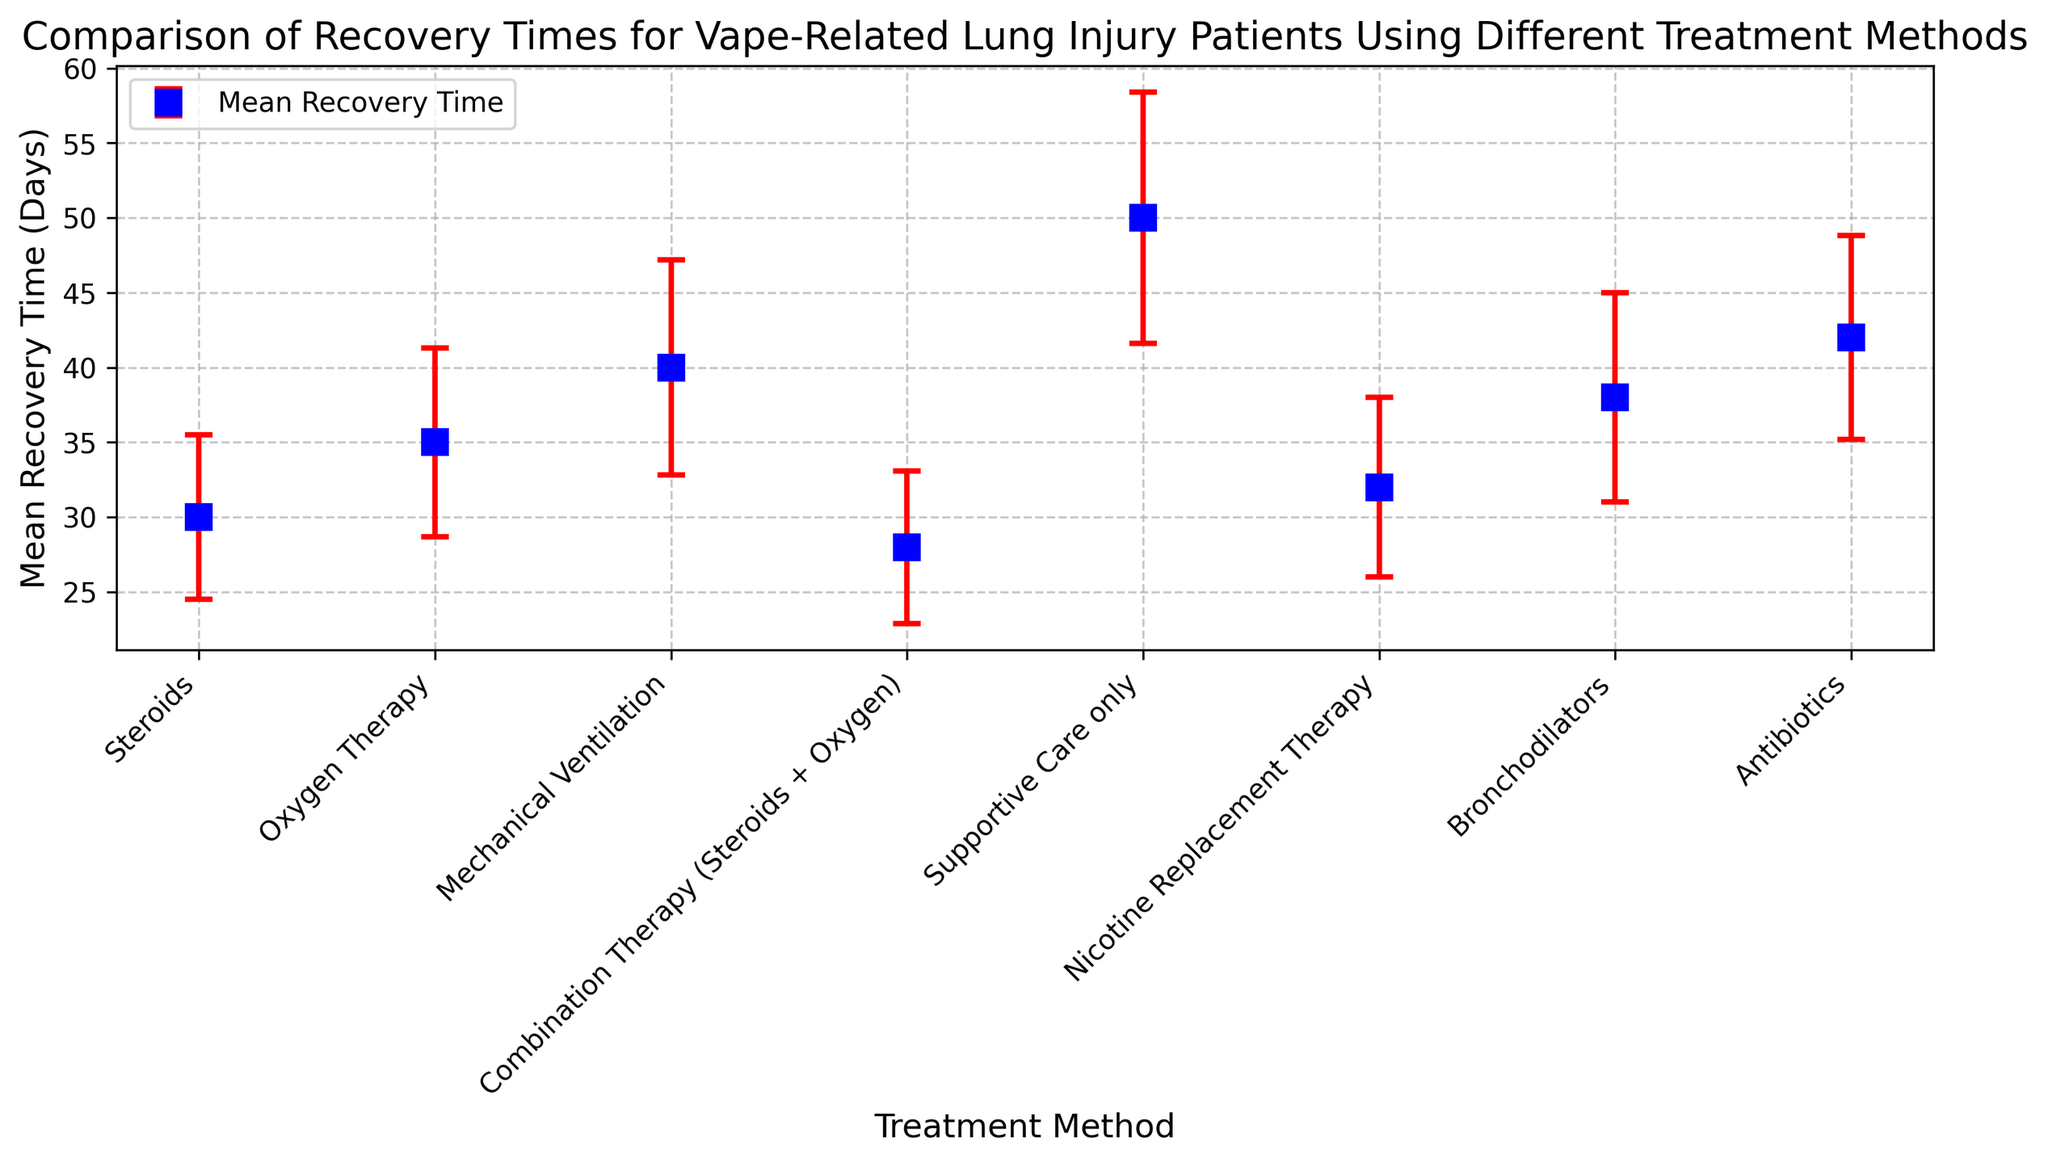What is the treatment method with the shortest mean recovery time? The figure shows the mean recovery time for each treatment method. By visually identifying the bar with the lowest value, we can see that Combination Therapy (Steroids + Oxygen) has the shortest mean recovery time.
Answer: Combination Therapy (Steroids + Oxygen) Which treatment method has the largest error bar? Error bars indicate the standard deviation for each treatment method's recovery time. The largest error bar, which visually stands out by its length, belongs to Supportive Care only.
Answer: Supportive Care only What is the difference in mean recovery time between Steroids and Antibiotics? The mean recovery time for Steroids is 30 days, and for Antibiotics, it is 42 days. Subtract 30 from 42 to get the difference.
Answer: 12 days Which treatment methods have a recovery time greater than 35 days? By scanning through the figure, we identify methods with mean recovery time above 35 days: Oxygen Therapy (35 days), Mechanical Ventilation (40 days), Bronchodilators (38 days), and Antibiotics (42 days).
Answer: Oxygen Therapy, Mechanical Ventilation, Bronchodilators, Antibiotics How does the error bar for Oxygen Therapy compare to that of Bronchodilators? Both error bars can be visually compared in the figure. The error bar for Bronchodilators (7.0 days) is longer than that for Oxygen Therapy (6.3 days).
Answer: Bronchodilators have a larger error bar If a patient is treated with Supportive Care only, how much longer is their mean recovery time compared to Combination Therapy (Steroids + Oxygen)? The mean recovery time for Supportive Care only is 50 days, and for Combination Therapy (Steroids + Oxygen) it is 28 days. Subtract 28 from 50.
Answer: 22 days Which treatment method has the largest sample size? By checking the sample sizes in the figure, we find that Steroids has the largest sample size at 30.
Answer: Steroids What is the difference between the mean recovery times of the second longest and second shortest recovery times? The second longest mean recovery time is Bronchodilators (38 days) and the second shortest is Steroids (30 days). Subtract 30 from 38.
Answer: 8 days Compare the mean recovery times of Mechanical Ventilation and Nicotine Replacement Therapy. Which is shorter? The mean recovery time for Mechanical Ventilation is 40 days, and for Nicotine Replacement Therapy, it is 32 days. Therefore, Nicotine Replacement Therapy has a shorter mean recovery time.
Answer: Nicotine Replacement Therapy Which treatment method has the closest mean recovery time to the overall average recovery time of all methods shown? Calculate the overall average by summing all the mean recovery times and dividing by the number of treatments: (30 + 35 + 40 + 28 + 50 + 32 + 38 + 42) / 8 = 36.625. Oxygen Therapy has a mean recovery time of 35 days, which is the closest.
Answer: Oxygen Therapy 